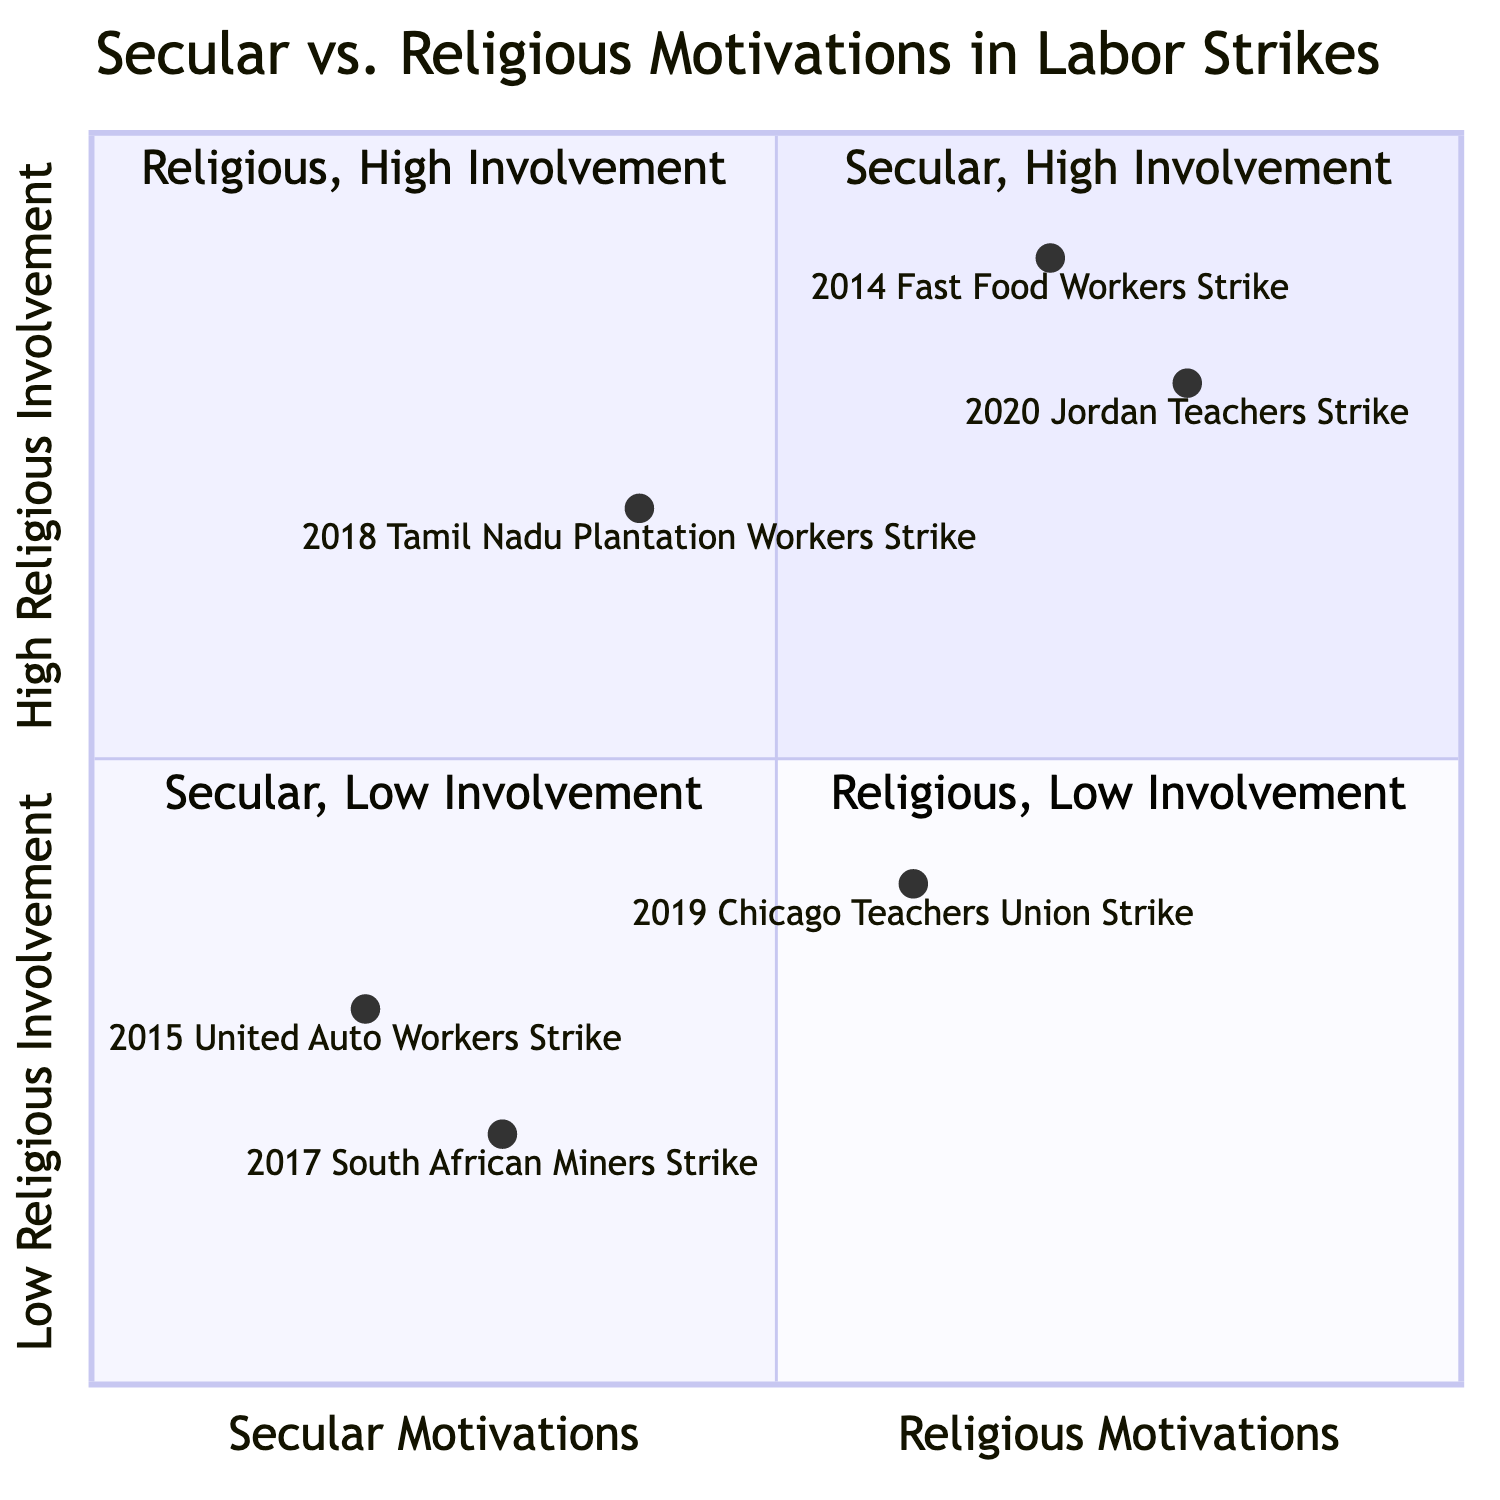What is the issue addressed in the 2015 United Auto Workers Strike? The diagram lists the issues for the 2015 United Auto Workers Strike as "wages", "benefits", and "working conditions". The issue is indicated directly in the node associated with this strike.
Answer: wages, benefits, working conditions Which strike had the highest religious involvement? By examining the quadrant placements in the diagram, the 2020 Jordan Teachers Strike is positioned in the "Religious, High Involvement" quadrant, suggesting it has the highest religious involvement among listed strikes.
Answer: 2020 Jordan Teachers Strike How many strikes address issues related to wages? The diagram shows that the following strikes mention "wages": 2015 United Auto Workers Strike, 2018 Tamil Nadu Plantation Workers Strike, 2019 Chicago Teachers Union Strike, 2020 Jordan Teachers Strike, and 2014 Fast Food Workers Strike. Counting these strikes reveals five that address wage issues.
Answer: 5 What is the primary motivation behind the 2014 Fast Food Workers Strike? The diagram indicates that the primary motivations for the 2014 Fast Food Workers Strike were "minimum wage increase" and "labor rights". This categorization is outlined in the related node.
Answer: minimum wage increase, labor rights Which quadrant contains secular strikes with high religious involvement? According to the diagram, there is no strike in the "Secular, High Involvement" quadrant; it is empty. Therefore, no secular strikes are categorized under high religious involvement.
Answer: None What issues were raised in the 2019 Chicago Teachers Union Strike? The relevant node for the 2019 Chicago Teachers Union Strike shows the issues raised were "funding for schools", "wages", and "support for students". This information is directly stated under the associated strike in the quadrant.
Answer: funding for schools, wages, support for students Which two strikes both involve issues related to wages and have high religious involvement? By analyzing the nodes that fall within the "Religious, High Involvement" quadrant, the 2020 Jordan Teachers Strike and the 2014 Fast Food Workers Strike both address wage issues and feature high religious involvement, as indicated in their respective descriptions.
Answer: 2020 Jordan Teachers Strike, 2014 Fast Food Workers Strike What was the primary issue for the 2018 Tamil Nadu Plantation Workers Strike? The diagram clearly states that the primary issues for the 2018 Tamil Nadu Plantation Workers Strike include "wages" and "plight of Dalit workers"; this text is directly associated with the strike's node in the quadrant.
Answer: wages, plight of Dalit workers 